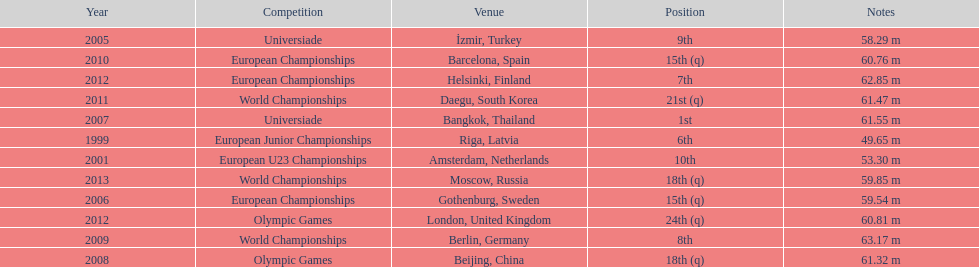What were the distances of mayer's throws? 49.65 m, 53.30 m, 58.29 m, 59.54 m, 61.55 m, 61.32 m, 63.17 m, 60.76 m, 61.47 m, 62.85 m, 60.81 m, 59.85 m. Which of these went the farthest? 63.17 m. 